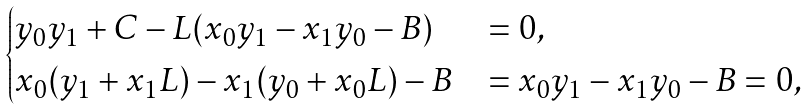Convert formula to latex. <formula><loc_0><loc_0><loc_500><loc_500>\begin{cases} y _ { 0 } y _ { 1 } + C - L ( x _ { 0 } y _ { 1 } - x _ { 1 } y _ { 0 } - B ) & = 0 , \\ x _ { 0 } ( y _ { 1 } + x _ { 1 } L ) - x _ { 1 } ( y _ { 0 } + x _ { 0 } L ) - B & = x _ { 0 } y _ { 1 } - x _ { 1 } y _ { 0 } - B = 0 , \end{cases}</formula> 